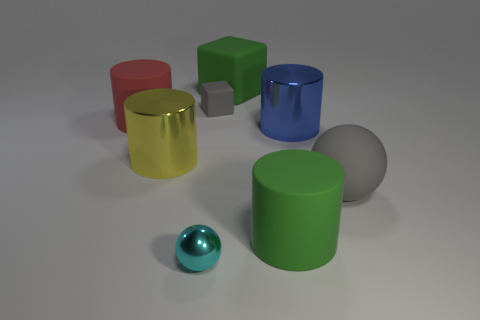Add 1 green cylinders. How many objects exist? 9 Subtract all balls. How many objects are left? 6 Add 7 big blue objects. How many big blue objects are left? 8 Add 4 big red matte things. How many big red matte things exist? 5 Subtract 0 brown blocks. How many objects are left? 8 Subtract all big gray rubber things. Subtract all cyan metallic spheres. How many objects are left? 6 